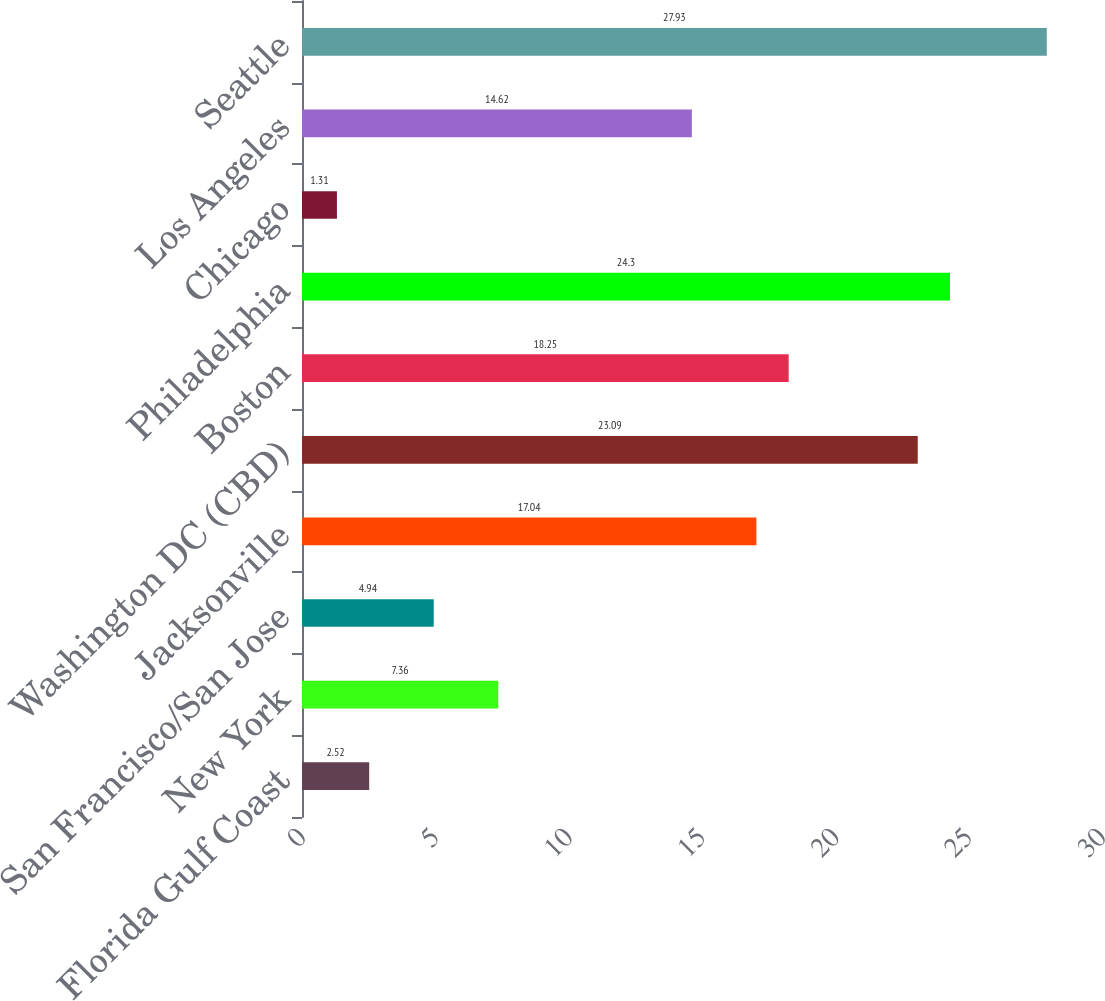Convert chart to OTSL. <chart><loc_0><loc_0><loc_500><loc_500><bar_chart><fcel>Florida Gulf Coast<fcel>New York<fcel>San Francisco/San Jose<fcel>Jacksonville<fcel>Washington DC (CBD)<fcel>Boston<fcel>Philadelphia<fcel>Chicago<fcel>Los Angeles<fcel>Seattle<nl><fcel>2.52<fcel>7.36<fcel>4.94<fcel>17.04<fcel>23.09<fcel>18.25<fcel>24.3<fcel>1.31<fcel>14.62<fcel>27.93<nl></chart> 